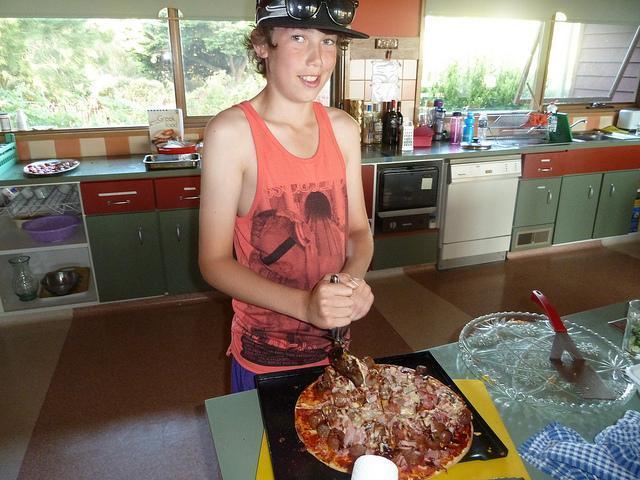Does the caption "The person is away from the dining table." correctly depict the image?
Answer yes or no. No. 